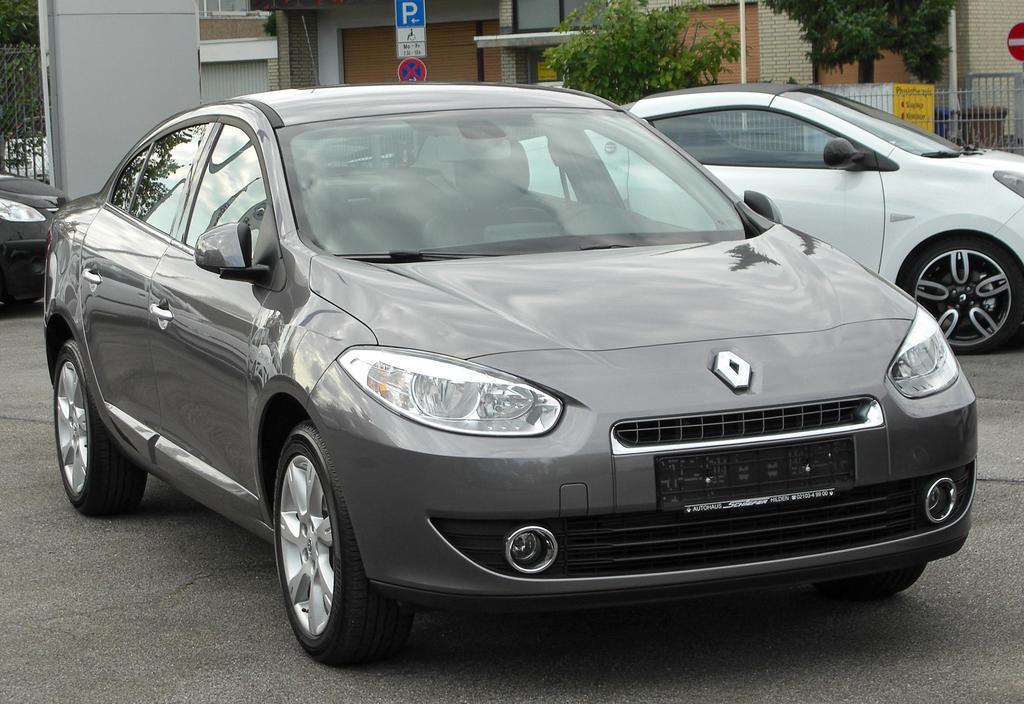In one or two sentences, can you explain what this image depicts? In this image, we can see a car is parked on the road. Background we can see few vehicles, walls, houses, trees, sign boards, grills, pillar and poles. 